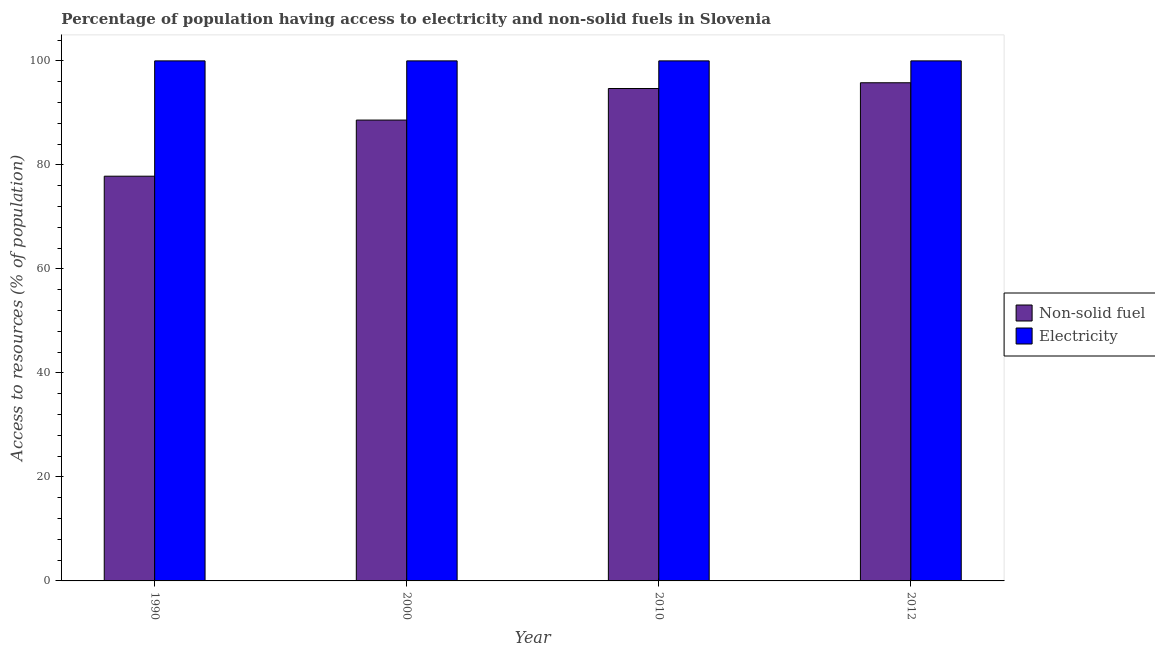Are the number of bars on each tick of the X-axis equal?
Ensure brevity in your answer.  Yes. How many bars are there on the 4th tick from the left?
Make the answer very short. 2. What is the label of the 1st group of bars from the left?
Offer a very short reply. 1990. What is the percentage of population having access to electricity in 2010?
Make the answer very short. 100. Across all years, what is the maximum percentage of population having access to electricity?
Make the answer very short. 100. Across all years, what is the minimum percentage of population having access to electricity?
Make the answer very short. 100. In which year was the percentage of population having access to non-solid fuel maximum?
Provide a short and direct response. 2012. What is the total percentage of population having access to electricity in the graph?
Provide a short and direct response. 400. What is the average percentage of population having access to electricity per year?
Make the answer very short. 100. In the year 2010, what is the difference between the percentage of population having access to electricity and percentage of population having access to non-solid fuel?
Your response must be concise. 0. In how many years, is the percentage of population having access to non-solid fuel greater than 72 %?
Offer a very short reply. 4. What is the ratio of the percentage of population having access to non-solid fuel in 2000 to that in 2010?
Your response must be concise. 0.94. Is the percentage of population having access to electricity in 2000 less than that in 2012?
Make the answer very short. No. What is the difference between the highest and the second highest percentage of population having access to electricity?
Your answer should be compact. 0. What is the difference between the highest and the lowest percentage of population having access to non-solid fuel?
Give a very brief answer. 17.97. Is the sum of the percentage of population having access to non-solid fuel in 1990 and 2010 greater than the maximum percentage of population having access to electricity across all years?
Your answer should be compact. Yes. What does the 1st bar from the left in 2010 represents?
Your response must be concise. Non-solid fuel. What does the 2nd bar from the right in 2010 represents?
Your answer should be very brief. Non-solid fuel. How many bars are there?
Your response must be concise. 8. What is the difference between two consecutive major ticks on the Y-axis?
Your response must be concise. 20. Does the graph contain any zero values?
Keep it short and to the point. No. Does the graph contain grids?
Your answer should be very brief. No. What is the title of the graph?
Your response must be concise. Percentage of population having access to electricity and non-solid fuels in Slovenia. What is the label or title of the Y-axis?
Your response must be concise. Access to resources (% of population). What is the Access to resources (% of population) in Non-solid fuel in 1990?
Provide a succinct answer. 77.82. What is the Access to resources (% of population) of Non-solid fuel in 2000?
Your answer should be very brief. 88.62. What is the Access to resources (% of population) of Electricity in 2000?
Ensure brevity in your answer.  100. What is the Access to resources (% of population) in Non-solid fuel in 2010?
Your response must be concise. 94.69. What is the Access to resources (% of population) of Electricity in 2010?
Your response must be concise. 100. What is the Access to resources (% of population) in Non-solid fuel in 2012?
Provide a short and direct response. 95.79. Across all years, what is the maximum Access to resources (% of population) of Non-solid fuel?
Provide a succinct answer. 95.79. Across all years, what is the minimum Access to resources (% of population) of Non-solid fuel?
Your answer should be compact. 77.82. Across all years, what is the minimum Access to resources (% of population) in Electricity?
Offer a terse response. 100. What is the total Access to resources (% of population) of Non-solid fuel in the graph?
Your answer should be compact. 356.93. What is the total Access to resources (% of population) of Electricity in the graph?
Keep it short and to the point. 400. What is the difference between the Access to resources (% of population) in Non-solid fuel in 1990 and that in 2000?
Provide a succinct answer. -10.79. What is the difference between the Access to resources (% of population) in Non-solid fuel in 1990 and that in 2010?
Your answer should be compact. -16.86. What is the difference between the Access to resources (% of population) of Electricity in 1990 and that in 2010?
Provide a short and direct response. 0. What is the difference between the Access to resources (% of population) in Non-solid fuel in 1990 and that in 2012?
Provide a short and direct response. -17.97. What is the difference between the Access to resources (% of population) of Non-solid fuel in 2000 and that in 2010?
Your response must be concise. -6.07. What is the difference between the Access to resources (% of population) in Non-solid fuel in 2000 and that in 2012?
Give a very brief answer. -7.17. What is the difference between the Access to resources (% of population) in Electricity in 2000 and that in 2012?
Keep it short and to the point. 0. What is the difference between the Access to resources (% of population) of Non-solid fuel in 2010 and that in 2012?
Provide a succinct answer. -1.11. What is the difference between the Access to resources (% of population) in Electricity in 2010 and that in 2012?
Provide a short and direct response. 0. What is the difference between the Access to resources (% of population) in Non-solid fuel in 1990 and the Access to resources (% of population) in Electricity in 2000?
Ensure brevity in your answer.  -22.18. What is the difference between the Access to resources (% of population) in Non-solid fuel in 1990 and the Access to resources (% of population) in Electricity in 2010?
Your answer should be compact. -22.18. What is the difference between the Access to resources (% of population) in Non-solid fuel in 1990 and the Access to resources (% of population) in Electricity in 2012?
Make the answer very short. -22.18. What is the difference between the Access to resources (% of population) in Non-solid fuel in 2000 and the Access to resources (% of population) in Electricity in 2010?
Keep it short and to the point. -11.38. What is the difference between the Access to resources (% of population) in Non-solid fuel in 2000 and the Access to resources (% of population) in Electricity in 2012?
Give a very brief answer. -11.38. What is the difference between the Access to resources (% of population) of Non-solid fuel in 2010 and the Access to resources (% of population) of Electricity in 2012?
Your response must be concise. -5.31. What is the average Access to resources (% of population) of Non-solid fuel per year?
Offer a terse response. 89.23. What is the average Access to resources (% of population) of Electricity per year?
Provide a succinct answer. 100. In the year 1990, what is the difference between the Access to resources (% of population) in Non-solid fuel and Access to resources (% of population) in Electricity?
Offer a terse response. -22.18. In the year 2000, what is the difference between the Access to resources (% of population) of Non-solid fuel and Access to resources (% of population) of Electricity?
Offer a terse response. -11.38. In the year 2010, what is the difference between the Access to resources (% of population) in Non-solid fuel and Access to resources (% of population) in Electricity?
Ensure brevity in your answer.  -5.31. In the year 2012, what is the difference between the Access to resources (% of population) of Non-solid fuel and Access to resources (% of population) of Electricity?
Provide a succinct answer. -4.21. What is the ratio of the Access to resources (% of population) of Non-solid fuel in 1990 to that in 2000?
Offer a very short reply. 0.88. What is the ratio of the Access to resources (% of population) of Non-solid fuel in 1990 to that in 2010?
Offer a very short reply. 0.82. What is the ratio of the Access to resources (% of population) in Non-solid fuel in 1990 to that in 2012?
Provide a succinct answer. 0.81. What is the ratio of the Access to resources (% of population) in Electricity in 1990 to that in 2012?
Your answer should be compact. 1. What is the ratio of the Access to resources (% of population) of Non-solid fuel in 2000 to that in 2010?
Give a very brief answer. 0.94. What is the ratio of the Access to resources (% of population) in Non-solid fuel in 2000 to that in 2012?
Provide a succinct answer. 0.93. What is the difference between the highest and the second highest Access to resources (% of population) in Non-solid fuel?
Offer a terse response. 1.11. What is the difference between the highest and the lowest Access to resources (% of population) in Non-solid fuel?
Your answer should be very brief. 17.97. What is the difference between the highest and the lowest Access to resources (% of population) in Electricity?
Give a very brief answer. 0. 